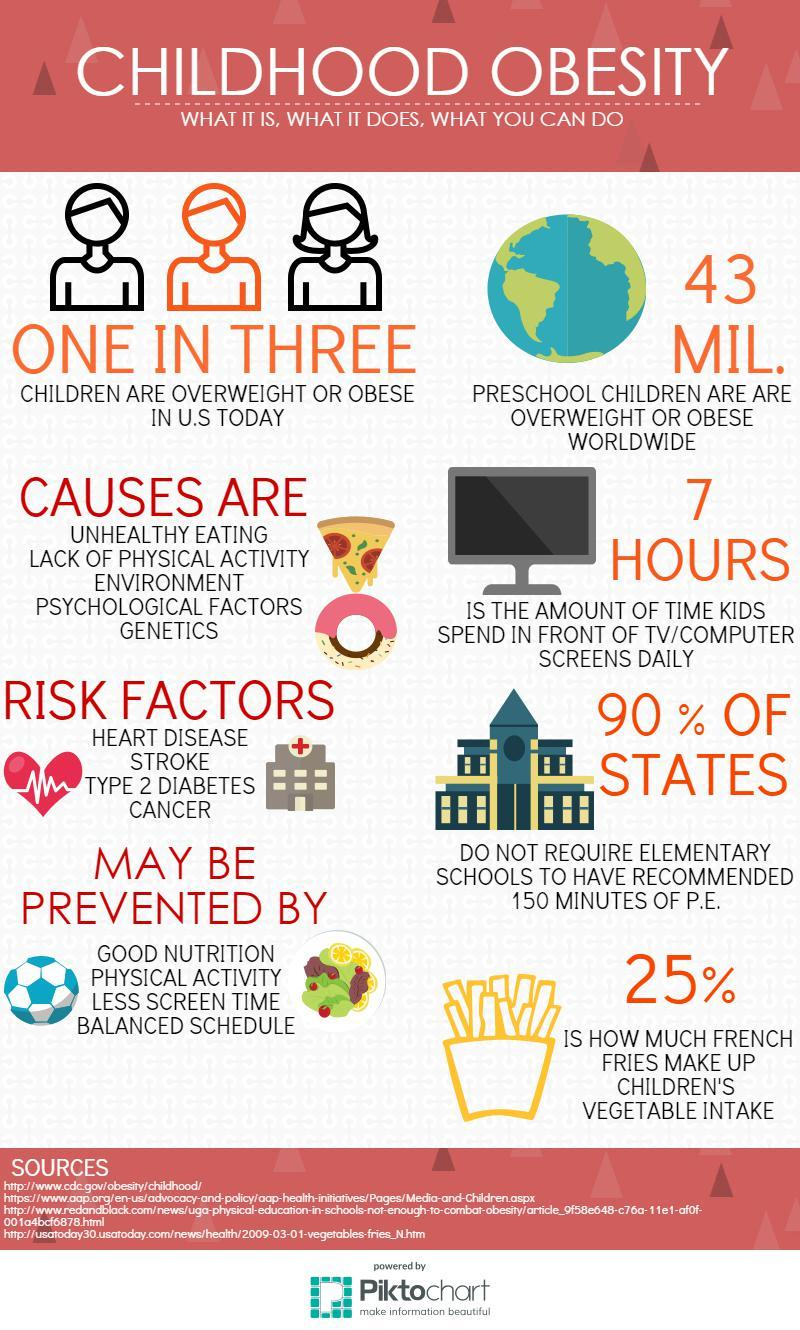Highlight a few significant elements in this photo. There are five reasons for childhood obesity. The fourth reason for childhood obesity in the infographic is psychological factors. There are 4 known risk factors for childhood obesity. The infographic lists genetics as the fifth reason for childhood obesity. Out of the 3 children, 2 of them are not overweight. 